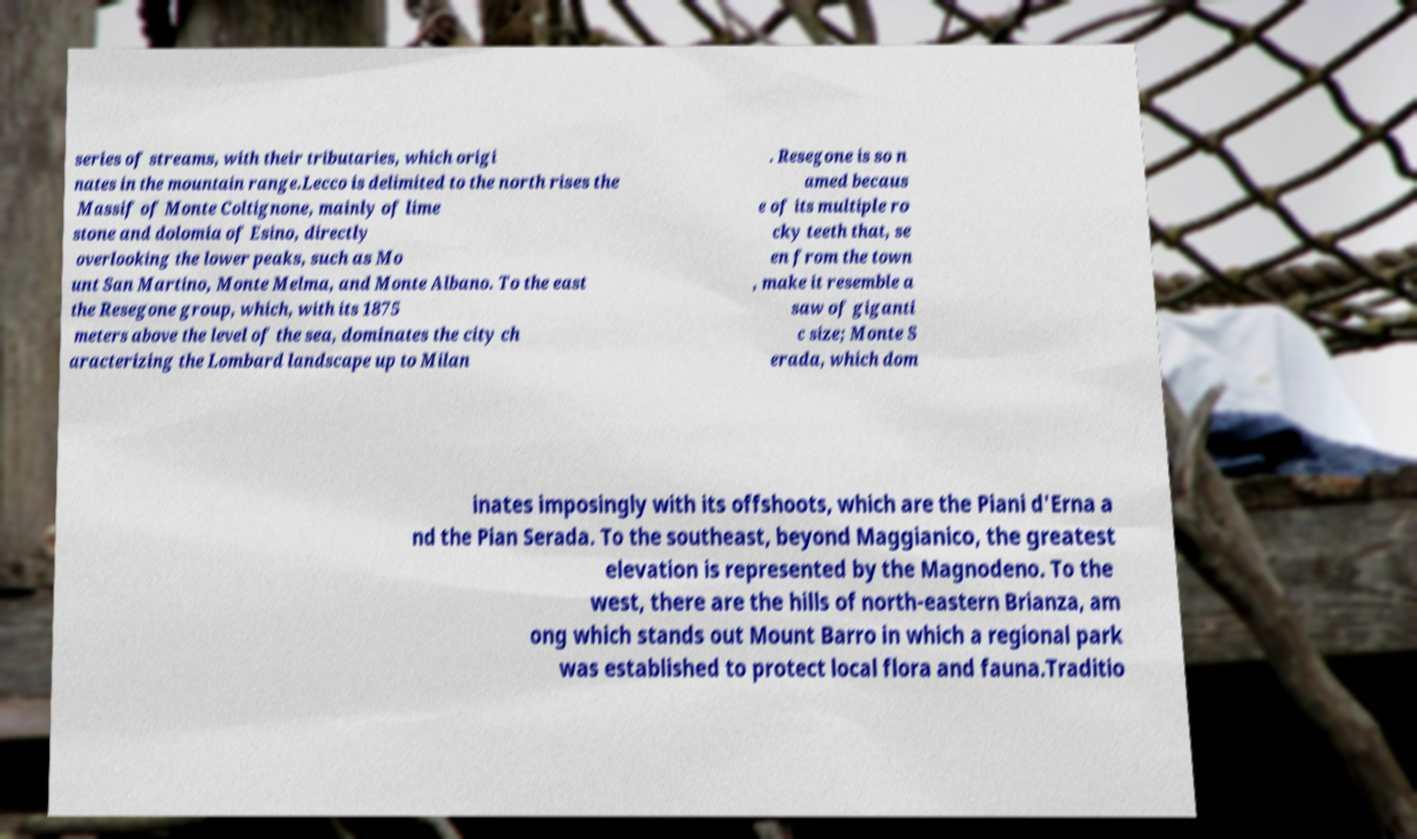I need the written content from this picture converted into text. Can you do that? series of streams, with their tributaries, which origi nates in the mountain range.Lecco is delimited to the north rises the Massif of Monte Coltignone, mainly of lime stone and dolomia of Esino, directly overlooking the lower peaks, such as Mo unt San Martino, Monte Melma, and Monte Albano. To the east the Resegone group, which, with its 1875 meters above the level of the sea, dominates the city ch aracterizing the Lombard landscape up to Milan . Resegone is so n amed becaus e of its multiple ro cky teeth that, se en from the town , make it resemble a saw of giganti c size; Monte S erada, which dom inates imposingly with its offshoots, which are the Piani d'Erna a nd the Pian Serada. To the southeast, beyond Maggianico, the greatest elevation is represented by the Magnodeno. To the west, there are the hills of north-eastern Brianza, am ong which stands out Mount Barro in which a regional park was established to protect local flora and fauna.Traditio 